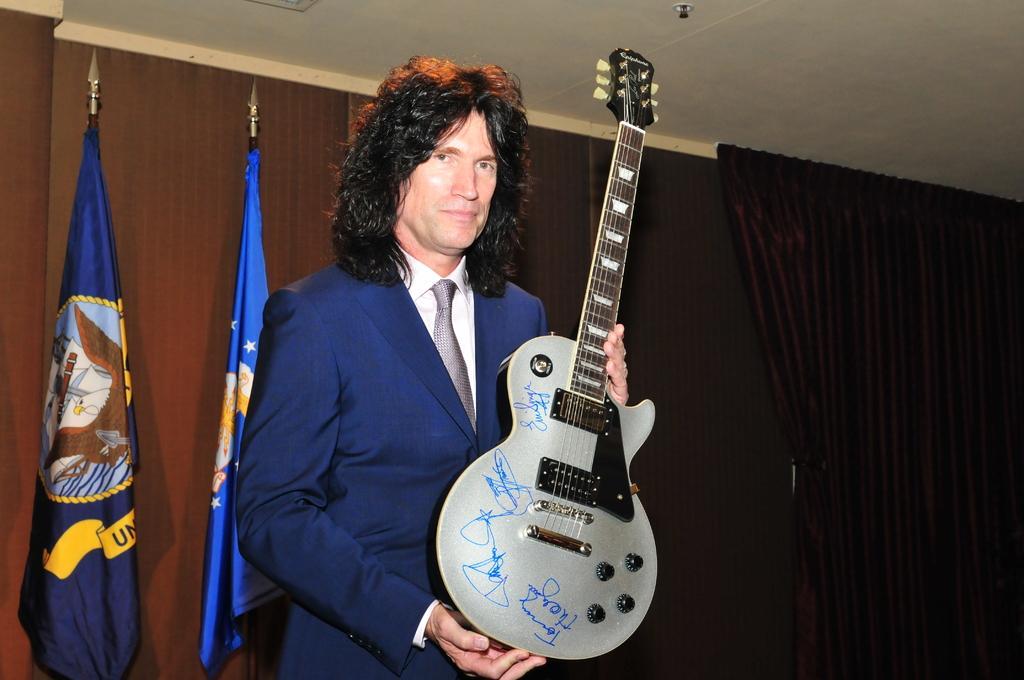How would you summarize this image in a sentence or two? The picture consists of a man wearing a blue jacket with long hair holding a guitar and back side of him there are two flags. 